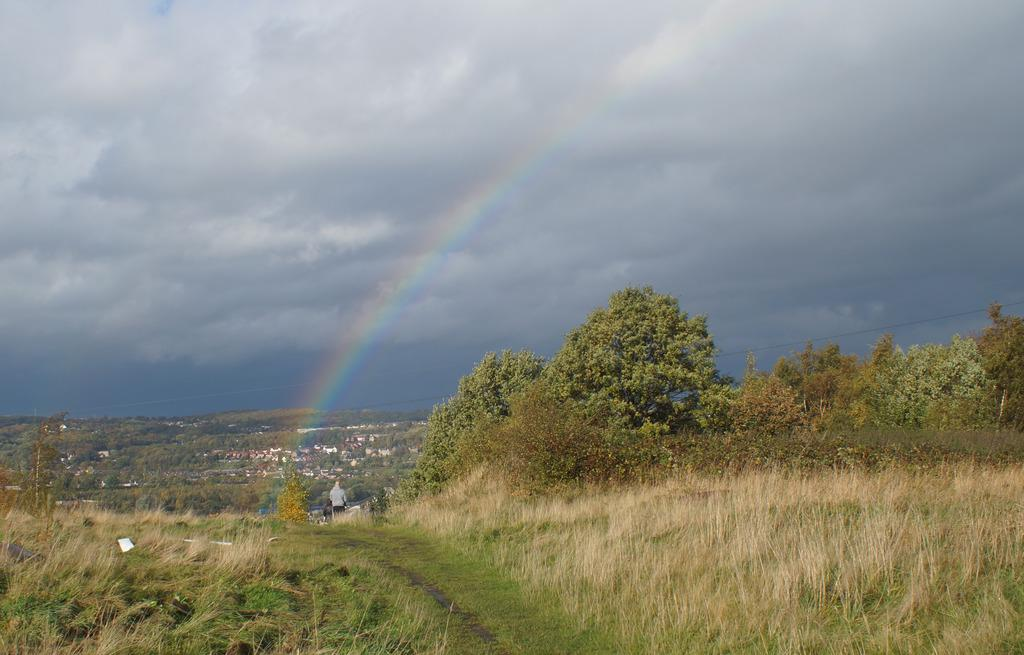What is the main subject of the image? There is a person standing in the image. What type of natural environment is visible in the image? There is grass in the image. What type of man-made structures can be seen in the image? There are buildings in the image. What type of vegetation is present in the image? There are trees in the image. What can be seen in the sky in the background of the image? There is a rainbow in the sky in the background of the image. What type of crate is being used for teaching in the image? There is no crate or teaching activity present in the image. What type of clouds can be seen in the sky in the image? The provided facts do not mention any clouds in the sky; only a rainbow is mentioned. 